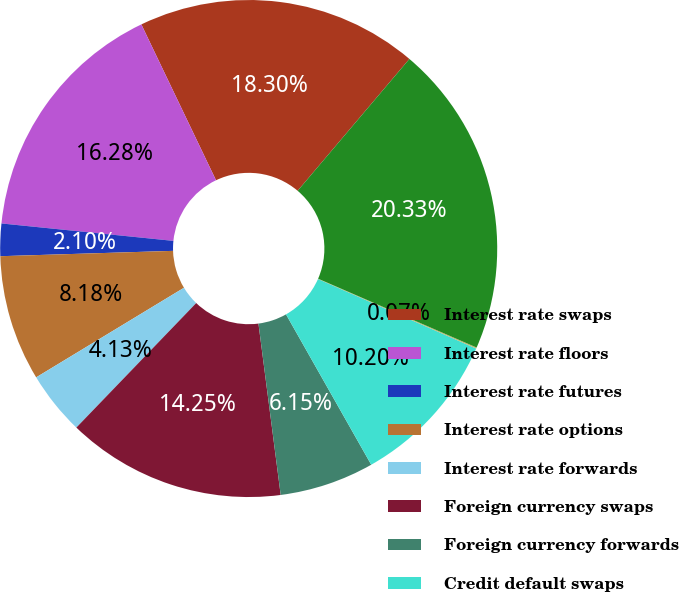Convert chart. <chart><loc_0><loc_0><loc_500><loc_500><pie_chart><fcel>Interest rate swaps<fcel>Interest rate floors<fcel>Interest rate futures<fcel>Interest rate options<fcel>Interest rate forwards<fcel>Foreign currency swaps<fcel>Foreign currency forwards<fcel>Credit default swaps<fcel>Equity futures<fcel>Equity options<nl><fcel>18.3%<fcel>16.28%<fcel>2.1%<fcel>8.18%<fcel>4.13%<fcel>14.25%<fcel>6.15%<fcel>10.2%<fcel>0.07%<fcel>20.33%<nl></chart> 